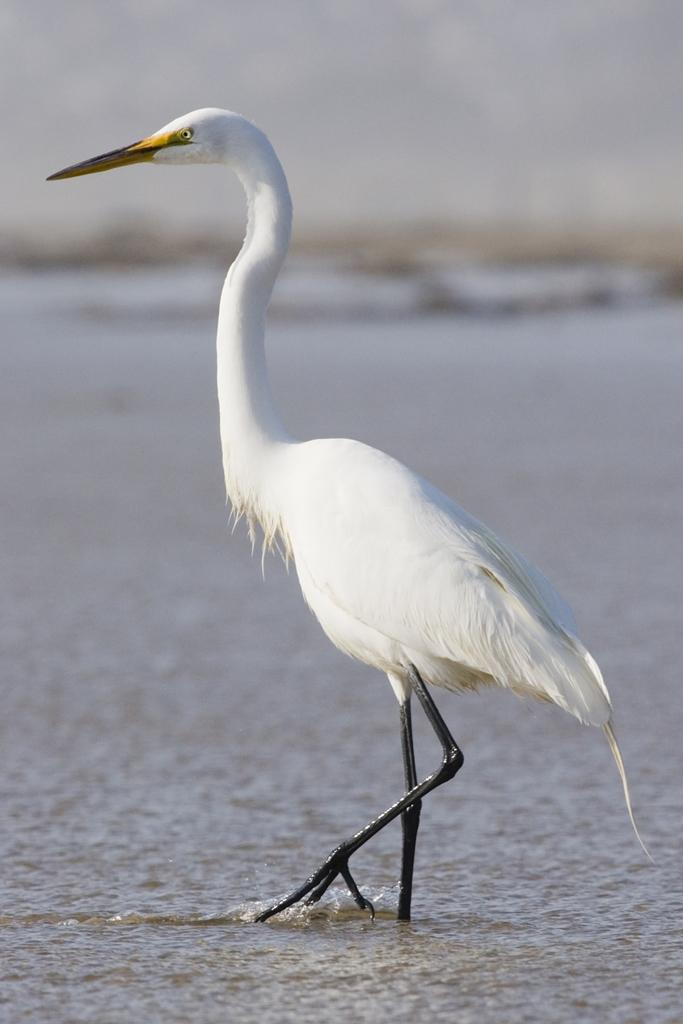What is the main subject of the image? The main subject of the image is a crane. What is the crane doing in the image? The crane is walking in the water. Reasoning: Let'g: Let's think step by step in order to produce the conversation. We start by identifying the main subject of the image, which is the crane. Then, we describe the action of the crane, which is walking in the water. We avoid yes/no questions and ensure that the language is simple and clear. Absurd Question/Answer: Where is the father of the crane in the image? There is no father of the crane present in the image, as cranes are not living beings with parents. What type of fruit can be seen in the crane's beak in the image? There is no fruit, such as a banana, present in the image, as the crane is not holding anything in its beak. 